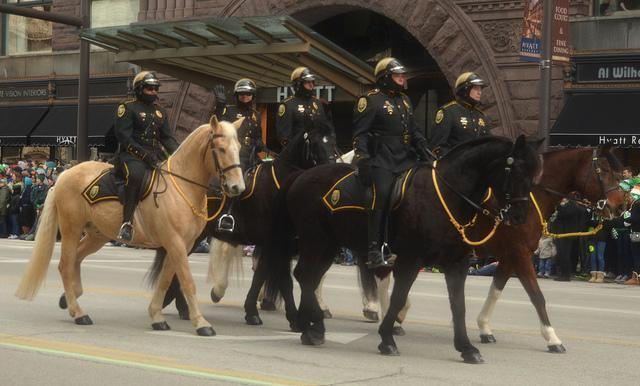What hotel is in the background behind the policemen and horses?
Pick the correct solution from the four options below to address the question.
Options: Best western, hilton, wyndham, hyatt. Hyatt. 